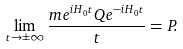Convert formula to latex. <formula><loc_0><loc_0><loc_500><loc_500>\lim _ { t \rightarrow \pm \infty } \frac { m e ^ { i H _ { 0 } t } { Q } e ^ { - i H _ { 0 } t } } { t } = { P } .</formula> 